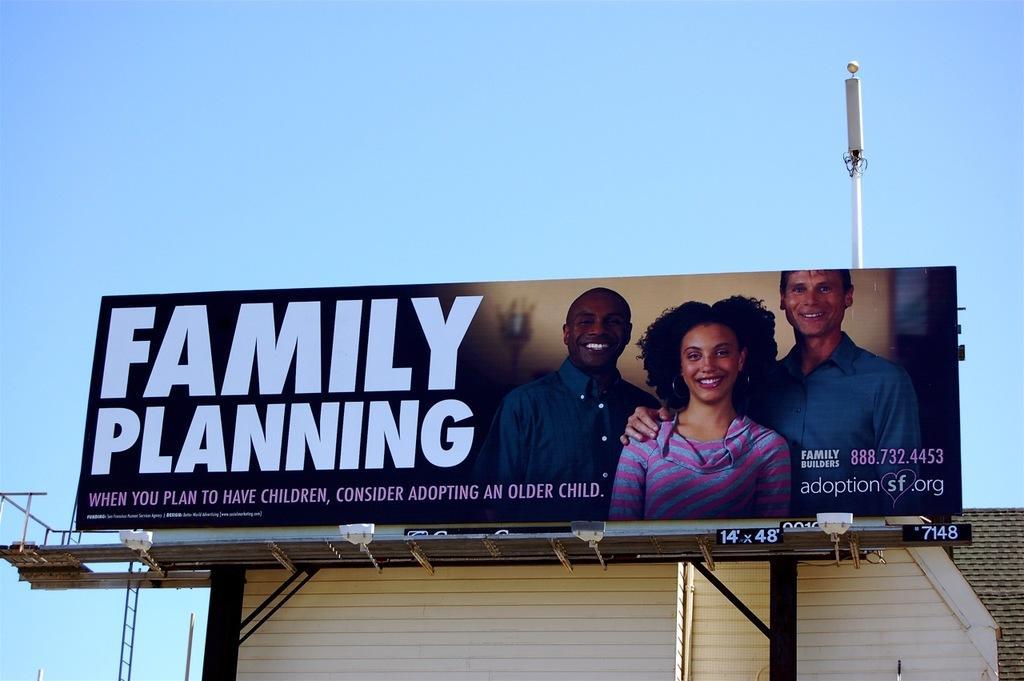How would you summarize this image in a sentence or two? In this image I can see a board, in the board I can see three persons. The person at right wearing blue color shirt and the person in the middle wearing blue and pink color dress and I can see something written on the board. Background I can see a house in white color and the sky is in blue color. 